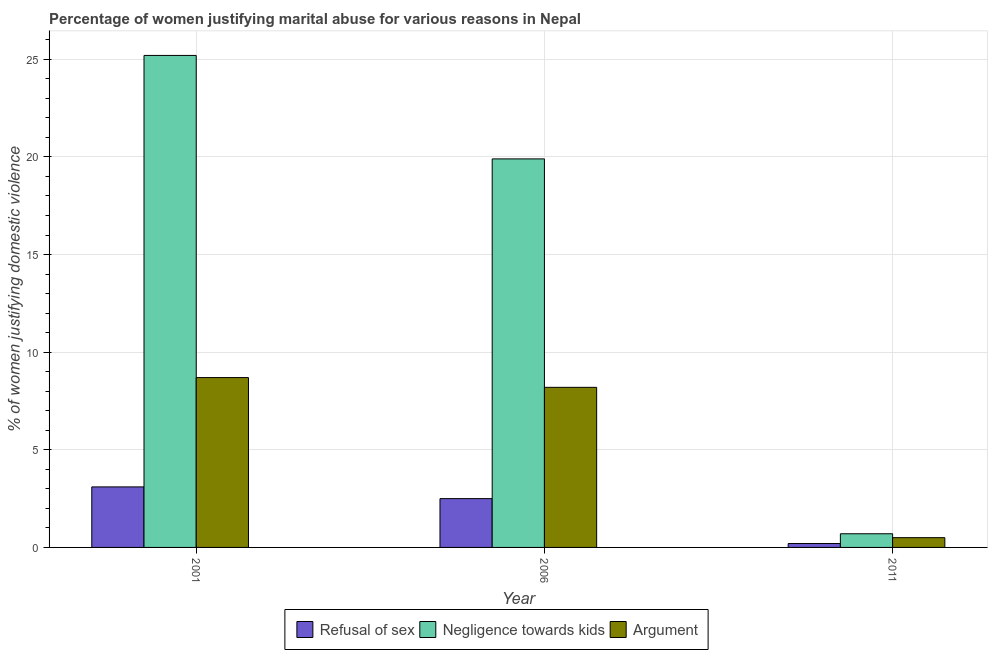How many different coloured bars are there?
Offer a very short reply. 3. How many bars are there on the 2nd tick from the left?
Your answer should be compact. 3. How many bars are there on the 2nd tick from the right?
Give a very brief answer. 3. What is the label of the 1st group of bars from the left?
Provide a short and direct response. 2001. What is the percentage of women justifying domestic violence due to arguments in 2006?
Ensure brevity in your answer.  8.2. Across all years, what is the maximum percentage of women justifying domestic violence due to negligence towards kids?
Offer a terse response. 25.2. What is the total percentage of women justifying domestic violence due to negligence towards kids in the graph?
Provide a short and direct response. 45.8. What is the difference between the percentage of women justifying domestic violence due to negligence towards kids in 2011 and the percentage of women justifying domestic violence due to arguments in 2006?
Provide a short and direct response. -19.2. What is the average percentage of women justifying domestic violence due to arguments per year?
Offer a terse response. 5.8. In how many years, is the percentage of women justifying domestic violence due to refusal of sex greater than 23 %?
Make the answer very short. 0. What is the difference between the highest and the second highest percentage of women justifying domestic violence due to arguments?
Provide a succinct answer. 0.5. What is the difference between the highest and the lowest percentage of women justifying domestic violence due to refusal of sex?
Your answer should be compact. 2.9. What does the 3rd bar from the left in 2006 represents?
Provide a short and direct response. Argument. What does the 3rd bar from the right in 2011 represents?
Provide a succinct answer. Refusal of sex. How many bars are there?
Give a very brief answer. 9. Are all the bars in the graph horizontal?
Provide a short and direct response. No. What is the difference between two consecutive major ticks on the Y-axis?
Your response must be concise. 5. Are the values on the major ticks of Y-axis written in scientific E-notation?
Your answer should be very brief. No. Does the graph contain any zero values?
Provide a succinct answer. No. Does the graph contain grids?
Give a very brief answer. Yes. Where does the legend appear in the graph?
Give a very brief answer. Bottom center. How many legend labels are there?
Keep it short and to the point. 3. How are the legend labels stacked?
Your answer should be very brief. Horizontal. What is the title of the graph?
Ensure brevity in your answer.  Percentage of women justifying marital abuse for various reasons in Nepal. Does "Liquid fuel" appear as one of the legend labels in the graph?
Give a very brief answer. No. What is the label or title of the Y-axis?
Keep it short and to the point. % of women justifying domestic violence. What is the % of women justifying domestic violence of Negligence towards kids in 2001?
Give a very brief answer. 25.2. What is the % of women justifying domestic violence of Argument in 2001?
Your answer should be very brief. 8.7. What is the % of women justifying domestic violence of Refusal of sex in 2006?
Provide a succinct answer. 2.5. What is the % of women justifying domestic violence of Argument in 2006?
Offer a very short reply. 8.2. What is the % of women justifying domestic violence of Negligence towards kids in 2011?
Your answer should be compact. 0.7. What is the % of women justifying domestic violence in Argument in 2011?
Keep it short and to the point. 0.5. Across all years, what is the maximum % of women justifying domestic violence in Refusal of sex?
Give a very brief answer. 3.1. Across all years, what is the maximum % of women justifying domestic violence in Negligence towards kids?
Give a very brief answer. 25.2. Across all years, what is the minimum % of women justifying domestic violence of Negligence towards kids?
Offer a very short reply. 0.7. What is the total % of women justifying domestic violence of Negligence towards kids in the graph?
Your response must be concise. 45.8. What is the total % of women justifying domestic violence in Argument in the graph?
Ensure brevity in your answer.  17.4. What is the difference between the % of women justifying domestic violence of Refusal of sex in 2001 and that in 2006?
Your answer should be compact. 0.6. What is the difference between the % of women justifying domestic violence in Argument in 2001 and that in 2006?
Offer a very short reply. 0.5. What is the difference between the % of women justifying domestic violence in Refusal of sex in 2001 and that in 2011?
Make the answer very short. 2.9. What is the difference between the % of women justifying domestic violence of Argument in 2001 and that in 2011?
Offer a terse response. 8.2. What is the difference between the % of women justifying domestic violence of Refusal of sex in 2006 and that in 2011?
Provide a short and direct response. 2.3. What is the difference between the % of women justifying domestic violence in Argument in 2006 and that in 2011?
Offer a very short reply. 7.7. What is the difference between the % of women justifying domestic violence of Refusal of sex in 2001 and the % of women justifying domestic violence of Negligence towards kids in 2006?
Offer a very short reply. -16.8. What is the difference between the % of women justifying domestic violence in Refusal of sex in 2001 and the % of women justifying domestic violence in Argument in 2006?
Make the answer very short. -5.1. What is the difference between the % of women justifying domestic violence of Negligence towards kids in 2001 and the % of women justifying domestic violence of Argument in 2006?
Your answer should be very brief. 17. What is the difference between the % of women justifying domestic violence of Refusal of sex in 2001 and the % of women justifying domestic violence of Argument in 2011?
Offer a terse response. 2.6. What is the difference between the % of women justifying domestic violence of Negligence towards kids in 2001 and the % of women justifying domestic violence of Argument in 2011?
Your answer should be compact. 24.7. What is the difference between the % of women justifying domestic violence of Negligence towards kids in 2006 and the % of women justifying domestic violence of Argument in 2011?
Your response must be concise. 19.4. What is the average % of women justifying domestic violence in Refusal of sex per year?
Offer a very short reply. 1.93. What is the average % of women justifying domestic violence of Negligence towards kids per year?
Offer a very short reply. 15.27. What is the average % of women justifying domestic violence in Argument per year?
Provide a short and direct response. 5.8. In the year 2001, what is the difference between the % of women justifying domestic violence of Refusal of sex and % of women justifying domestic violence of Negligence towards kids?
Your answer should be very brief. -22.1. In the year 2001, what is the difference between the % of women justifying domestic violence of Negligence towards kids and % of women justifying domestic violence of Argument?
Give a very brief answer. 16.5. In the year 2006, what is the difference between the % of women justifying domestic violence of Refusal of sex and % of women justifying domestic violence of Negligence towards kids?
Offer a very short reply. -17.4. In the year 2006, what is the difference between the % of women justifying domestic violence of Refusal of sex and % of women justifying domestic violence of Argument?
Ensure brevity in your answer.  -5.7. In the year 2011, what is the difference between the % of women justifying domestic violence of Refusal of sex and % of women justifying domestic violence of Negligence towards kids?
Your answer should be compact. -0.5. In the year 2011, what is the difference between the % of women justifying domestic violence in Refusal of sex and % of women justifying domestic violence in Argument?
Your response must be concise. -0.3. What is the ratio of the % of women justifying domestic violence of Refusal of sex in 2001 to that in 2006?
Provide a short and direct response. 1.24. What is the ratio of the % of women justifying domestic violence of Negligence towards kids in 2001 to that in 2006?
Your answer should be compact. 1.27. What is the ratio of the % of women justifying domestic violence of Argument in 2001 to that in 2006?
Keep it short and to the point. 1.06. What is the ratio of the % of women justifying domestic violence in Negligence towards kids in 2006 to that in 2011?
Keep it short and to the point. 28.43. What is the ratio of the % of women justifying domestic violence of Argument in 2006 to that in 2011?
Offer a very short reply. 16.4. What is the difference between the highest and the second highest % of women justifying domestic violence of Negligence towards kids?
Provide a short and direct response. 5.3. What is the difference between the highest and the second highest % of women justifying domestic violence of Argument?
Provide a short and direct response. 0.5. What is the difference between the highest and the lowest % of women justifying domestic violence of Negligence towards kids?
Provide a short and direct response. 24.5. What is the difference between the highest and the lowest % of women justifying domestic violence of Argument?
Provide a short and direct response. 8.2. 